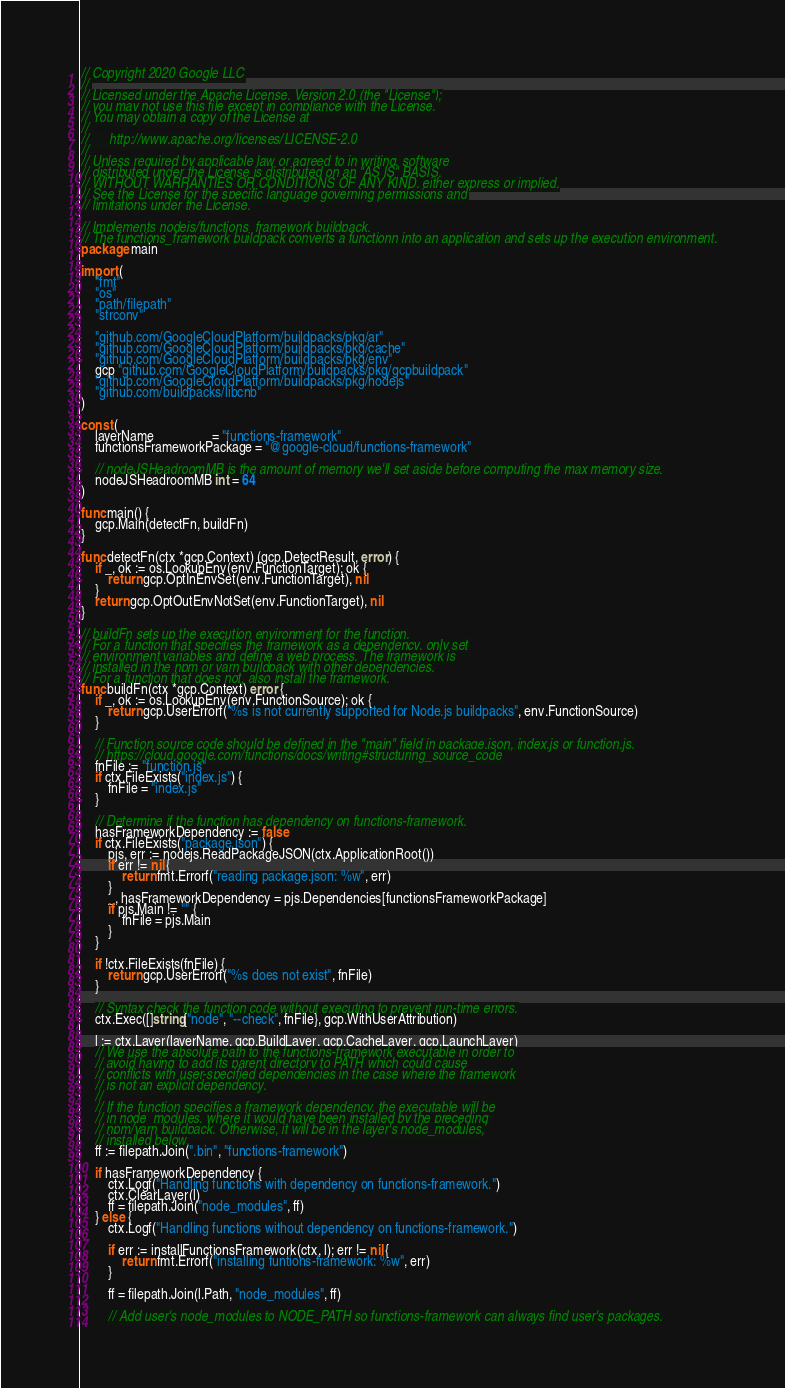Convert code to text. <code><loc_0><loc_0><loc_500><loc_500><_Go_>// Copyright 2020 Google LLC
//
// Licensed under the Apache License, Version 2.0 (the "License");
// you may not use this file except in compliance with the License.
// You may obtain a copy of the License at
//
//      http://www.apache.org/licenses/LICENSE-2.0
//
// Unless required by applicable law or agreed to in writing, software
// distributed under the License is distributed on an "AS IS" BASIS,
// WITHOUT WARRANTIES OR CONDITIONS OF ANY KIND, either express or implied.
// See the License for the specific language governing permissions and
// limitations under the License.

// Implements nodejs/functions_framework buildpack.
// The functions_framework buildpack converts a functionn into an application and sets up the execution environment.
package main

import (
	"fmt"
	"os"
	"path/filepath"
	"strconv"

	"github.com/GoogleCloudPlatform/buildpacks/pkg/ar"
	"github.com/GoogleCloudPlatform/buildpacks/pkg/cache"
	"github.com/GoogleCloudPlatform/buildpacks/pkg/env"
	gcp "github.com/GoogleCloudPlatform/buildpacks/pkg/gcpbuildpack"
	"github.com/GoogleCloudPlatform/buildpacks/pkg/nodejs"
	"github.com/buildpacks/libcnb"
)

const (
	layerName                 = "functions-framework"
	functionsFrameworkPackage = "@google-cloud/functions-framework"

	// nodeJSHeadroomMB is the amount of memory we'll set aside before computing the max memory size.
	nodeJSHeadroomMB int = 64
)

func main() {
	gcp.Main(detectFn, buildFn)
}

func detectFn(ctx *gcp.Context) (gcp.DetectResult, error) {
	if _, ok := os.LookupEnv(env.FunctionTarget); ok {
		return gcp.OptInEnvSet(env.FunctionTarget), nil
	}
	return gcp.OptOutEnvNotSet(env.FunctionTarget), nil
}

// buildFn sets up the execution environment for the function.
// For a function that specifies the framework as a dependency, only set
// environment variables and define a web process. The framework is
// installed in the npm or yarn buildpack with other dependencies.
// For a function that does not, also install the framework.
func buildFn(ctx *gcp.Context) error {
	if _, ok := os.LookupEnv(env.FunctionSource); ok {
		return gcp.UserErrorf("%s is not currently supported for Node.js buildpacks", env.FunctionSource)
	}

	// Function source code should be defined in the "main" field in package.json, index.js or function.js.
	// https://cloud.google.com/functions/docs/writing#structuring_source_code
	fnFile := "function.js"
	if ctx.FileExists("index.js") {
		fnFile = "index.js"
	}

	// Determine if the function has dependency on functions-framework.
	hasFrameworkDependency := false
	if ctx.FileExists("package.json") {
		pjs, err := nodejs.ReadPackageJSON(ctx.ApplicationRoot())
		if err != nil {
			return fmt.Errorf("reading package.json: %w", err)
		}
		_, hasFrameworkDependency = pjs.Dependencies[functionsFrameworkPackage]
		if pjs.Main != "" {
			fnFile = pjs.Main
		}
	}

	if !ctx.FileExists(fnFile) {
		return gcp.UserErrorf("%s does not exist", fnFile)
	}

	// Syntax check the function code without executing to prevent run-time errors.
	ctx.Exec([]string{"node", "--check", fnFile}, gcp.WithUserAttribution)

	l := ctx.Layer(layerName, gcp.BuildLayer, gcp.CacheLayer, gcp.LaunchLayer)
	// We use the absolute path to the functions-framework executable in order to
	// avoid having to add its parent directory to PATH which could cause
	// conflicts with user-specified dependencies in the case where the framework
	// is not an explicit dependency.
	//
	// If the function specifies a framework dependency, the executable will be
	// in node_modules, where it would have been installed by the preceding
	// npm/yarn buildpack. Otherwise, it will be in the layer's node_modules,
	// installed below.
	ff := filepath.Join(".bin", "functions-framework")

	if hasFrameworkDependency {
		ctx.Logf("Handling functions with dependency on functions-framework.")
		ctx.ClearLayer(l)
		ff = filepath.Join("node_modules", ff)
	} else {
		ctx.Logf("Handling functions without dependency on functions-framework.")

		if err := installFunctionsFramework(ctx, l); err != nil {
			return fmt.Errorf("installing funtions-framework: %w", err)
		}

		ff = filepath.Join(l.Path, "node_modules", ff)

		// Add user's node_modules to NODE_PATH so functions-framework can always find user's packages.</code> 